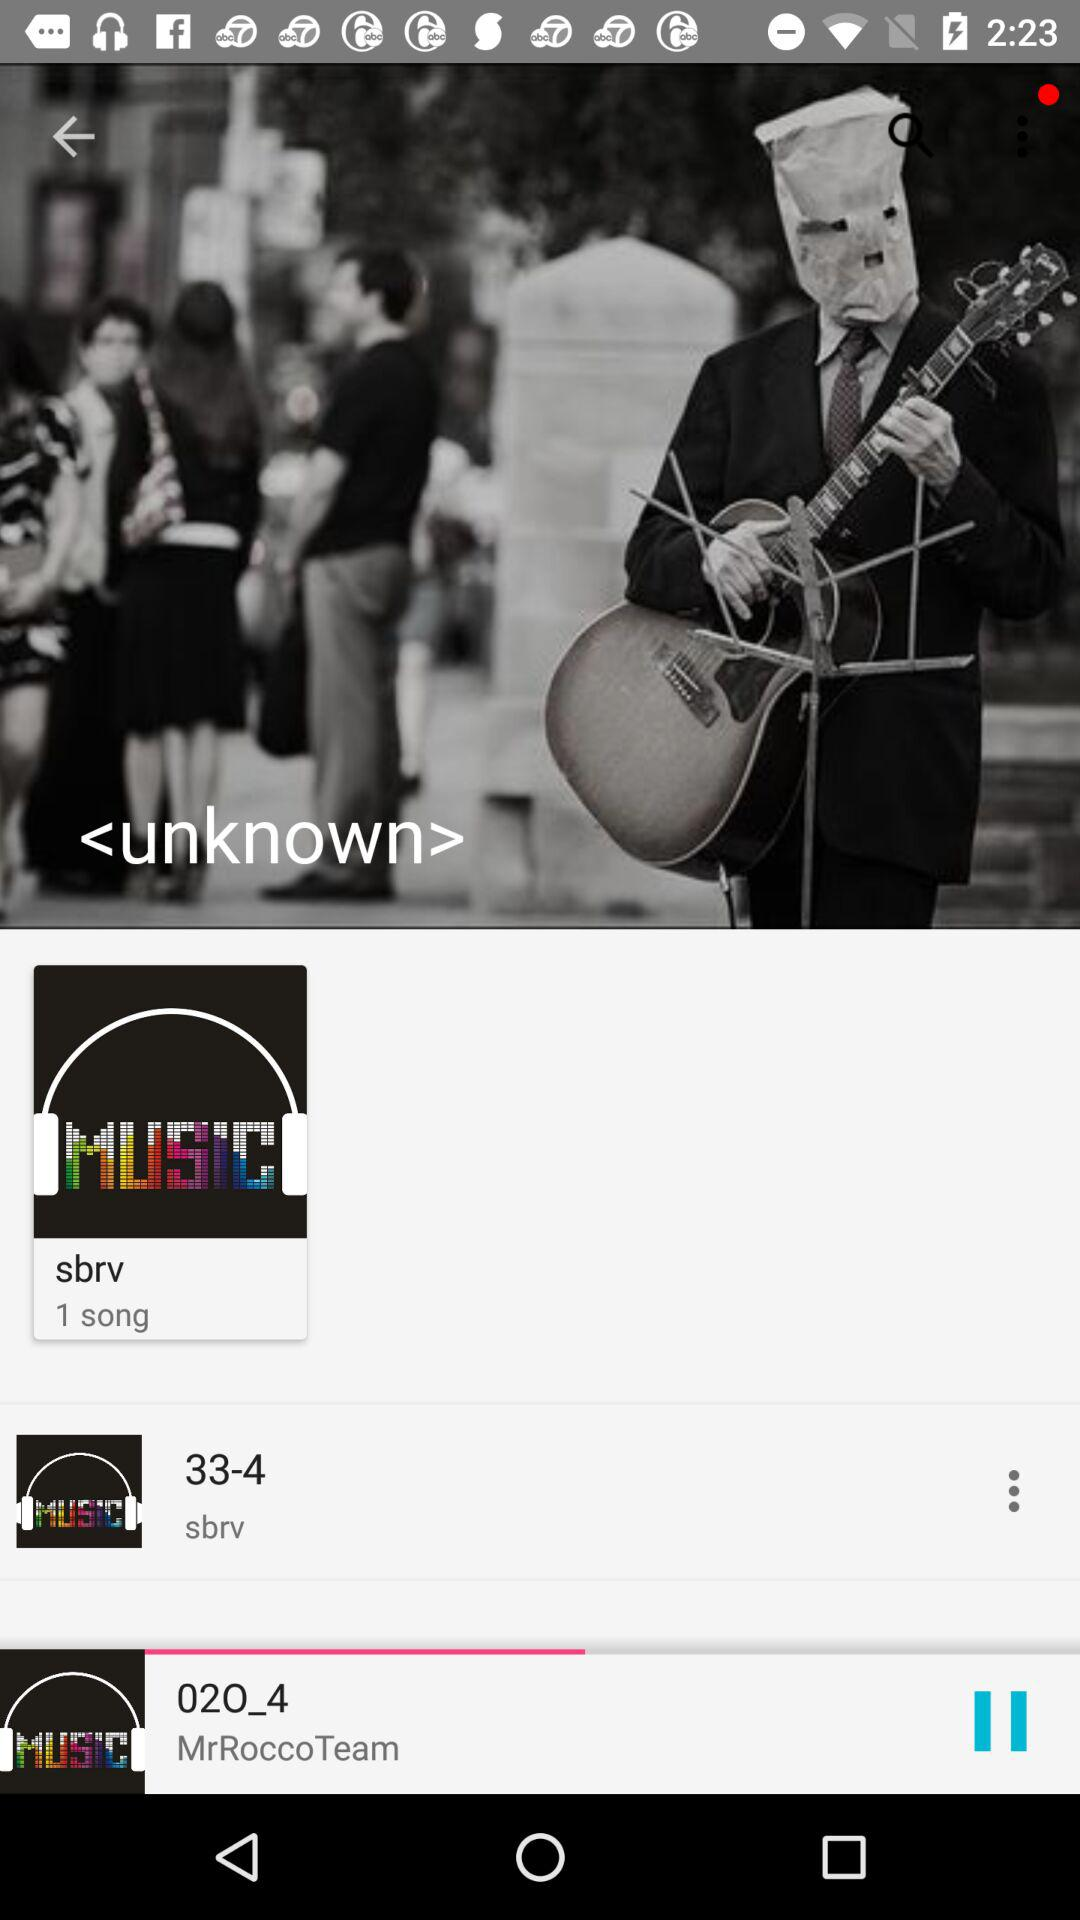33-4 belongs to which album? 33-4 belongs to the "sbrv" album. 